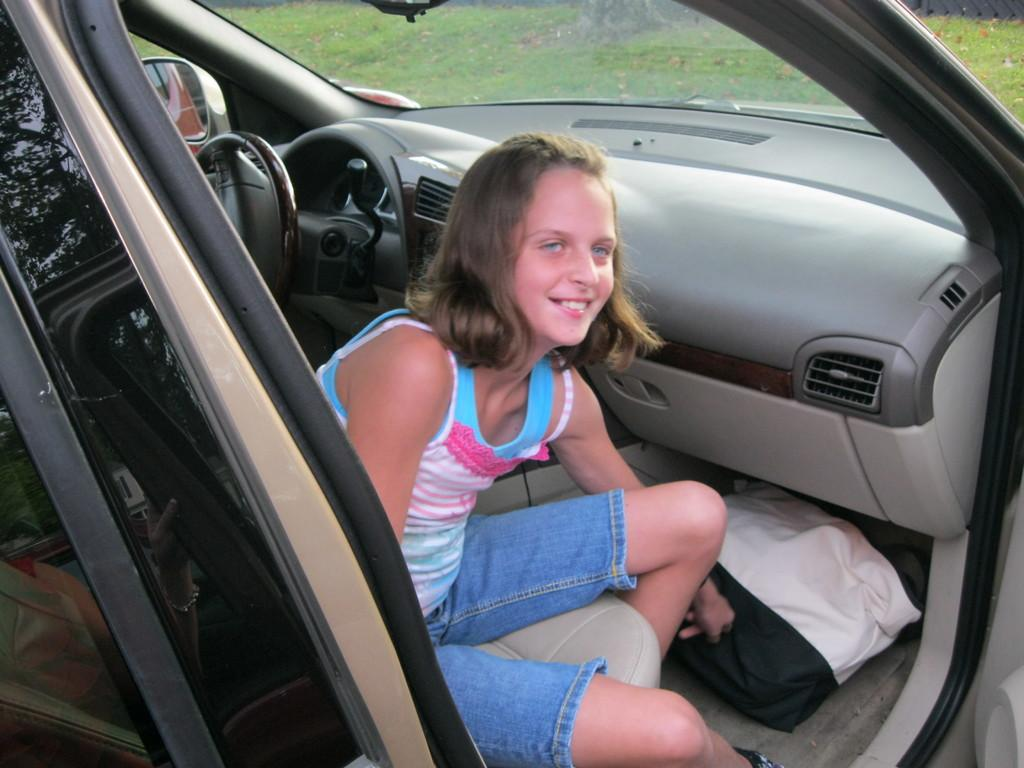Who is present in the image? There is a girl in the image. What is the girl doing in the image? The girl is smiling in the image. Where is the girl located in the image? The girl is sitting inside a car in the image. What can be seen beside the girl in the image? There is a bag beside the girl in the image. What features of the car can be identified in the image? The car has a steering wheel and a mirror in the image. What can be seen through the car's window in the image? Grass is visible through the car's window in the image. What type of shoes is the goat wearing in the image? There is no goat present in the image, and therefore no shoes to describe. 